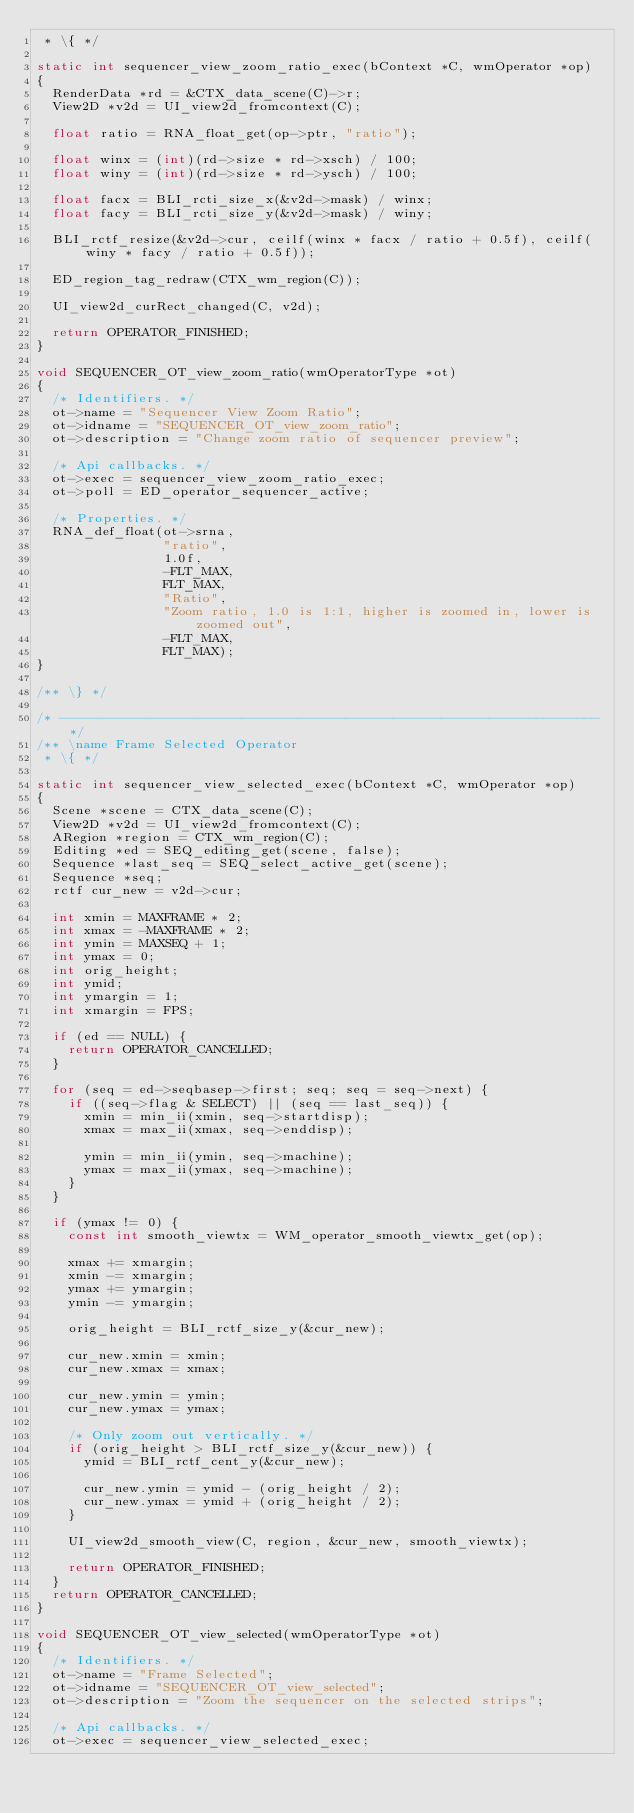Convert code to text. <code><loc_0><loc_0><loc_500><loc_500><_C_> * \{ */

static int sequencer_view_zoom_ratio_exec(bContext *C, wmOperator *op)
{
  RenderData *rd = &CTX_data_scene(C)->r;
  View2D *v2d = UI_view2d_fromcontext(C);

  float ratio = RNA_float_get(op->ptr, "ratio");

  float winx = (int)(rd->size * rd->xsch) / 100;
  float winy = (int)(rd->size * rd->ysch) / 100;

  float facx = BLI_rcti_size_x(&v2d->mask) / winx;
  float facy = BLI_rcti_size_y(&v2d->mask) / winy;

  BLI_rctf_resize(&v2d->cur, ceilf(winx * facx / ratio + 0.5f), ceilf(winy * facy / ratio + 0.5f));

  ED_region_tag_redraw(CTX_wm_region(C));

  UI_view2d_curRect_changed(C, v2d);

  return OPERATOR_FINISHED;
}

void SEQUENCER_OT_view_zoom_ratio(wmOperatorType *ot)
{
  /* Identifiers. */
  ot->name = "Sequencer View Zoom Ratio";
  ot->idname = "SEQUENCER_OT_view_zoom_ratio";
  ot->description = "Change zoom ratio of sequencer preview";

  /* Api callbacks. */
  ot->exec = sequencer_view_zoom_ratio_exec;
  ot->poll = ED_operator_sequencer_active;

  /* Properties. */
  RNA_def_float(ot->srna,
                "ratio",
                1.0f,
                -FLT_MAX,
                FLT_MAX,
                "Ratio",
                "Zoom ratio, 1.0 is 1:1, higher is zoomed in, lower is zoomed out",
                -FLT_MAX,
                FLT_MAX);
}

/** \} */

/* -------------------------------------------------------------------- */
/** \name Frame Selected Operator
 * \{ */

static int sequencer_view_selected_exec(bContext *C, wmOperator *op)
{
  Scene *scene = CTX_data_scene(C);
  View2D *v2d = UI_view2d_fromcontext(C);
  ARegion *region = CTX_wm_region(C);
  Editing *ed = SEQ_editing_get(scene, false);
  Sequence *last_seq = SEQ_select_active_get(scene);
  Sequence *seq;
  rctf cur_new = v2d->cur;

  int xmin = MAXFRAME * 2;
  int xmax = -MAXFRAME * 2;
  int ymin = MAXSEQ + 1;
  int ymax = 0;
  int orig_height;
  int ymid;
  int ymargin = 1;
  int xmargin = FPS;

  if (ed == NULL) {
    return OPERATOR_CANCELLED;
  }

  for (seq = ed->seqbasep->first; seq; seq = seq->next) {
    if ((seq->flag & SELECT) || (seq == last_seq)) {
      xmin = min_ii(xmin, seq->startdisp);
      xmax = max_ii(xmax, seq->enddisp);

      ymin = min_ii(ymin, seq->machine);
      ymax = max_ii(ymax, seq->machine);
    }
  }

  if (ymax != 0) {
    const int smooth_viewtx = WM_operator_smooth_viewtx_get(op);

    xmax += xmargin;
    xmin -= xmargin;
    ymax += ymargin;
    ymin -= ymargin;

    orig_height = BLI_rctf_size_y(&cur_new);

    cur_new.xmin = xmin;
    cur_new.xmax = xmax;

    cur_new.ymin = ymin;
    cur_new.ymax = ymax;

    /* Only zoom out vertically. */
    if (orig_height > BLI_rctf_size_y(&cur_new)) {
      ymid = BLI_rctf_cent_y(&cur_new);

      cur_new.ymin = ymid - (orig_height / 2);
      cur_new.ymax = ymid + (orig_height / 2);
    }

    UI_view2d_smooth_view(C, region, &cur_new, smooth_viewtx);

    return OPERATOR_FINISHED;
  }
  return OPERATOR_CANCELLED;
}

void SEQUENCER_OT_view_selected(wmOperatorType *ot)
{
  /* Identifiers. */
  ot->name = "Frame Selected";
  ot->idname = "SEQUENCER_OT_view_selected";
  ot->description = "Zoom the sequencer on the selected strips";

  /* Api callbacks. */
  ot->exec = sequencer_view_selected_exec;</code> 